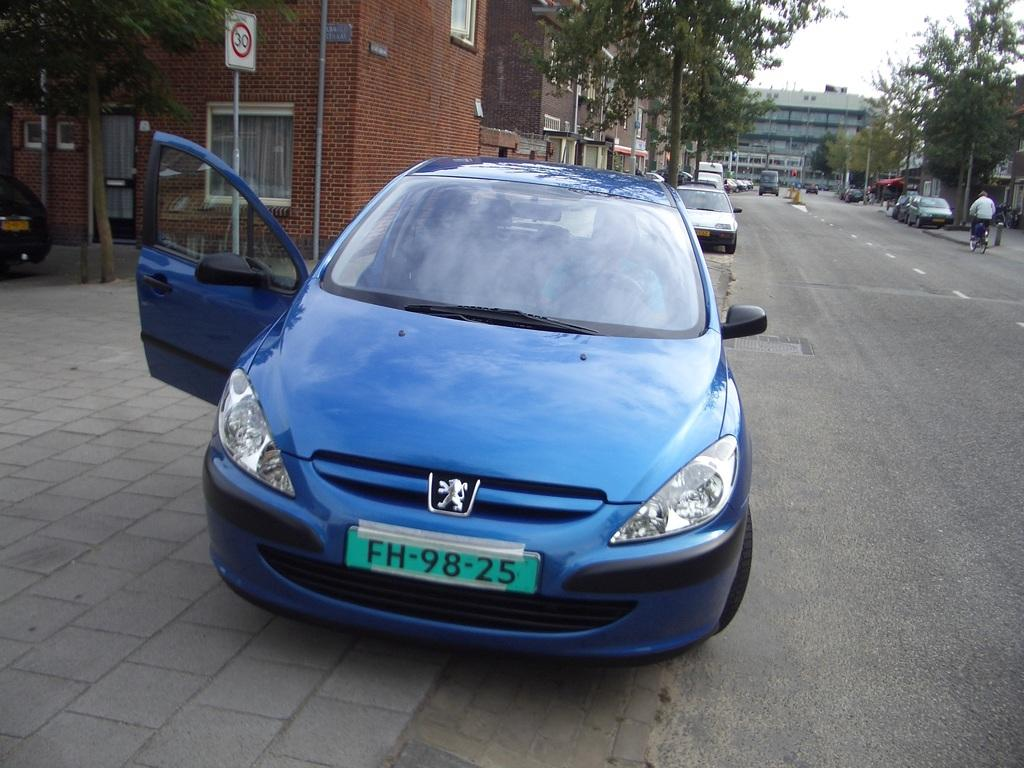<image>
Present a compact description of the photo's key features. Blue car parked outside with a license plate that says FH9825. 